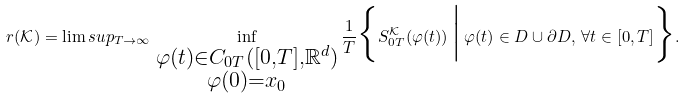Convert formula to latex. <formula><loc_0><loc_0><loc_500><loc_500>r ( \mathcal { K } ) = \lim s u p _ { T \rightarrow \infty } \, \inf _ { \substack { \varphi ( t ) \in C _ { 0 T } ( [ 0 , T ] , \mathbb { R } ^ { d } ) \\ \varphi ( 0 ) = x _ { 0 } } } \frac { 1 } { T } \Big \{ S _ { 0 T } ^ { \mathcal { K } } ( \varphi ( t ) ) \, \Big | \, \varphi ( t ) \in D \cup \partial D , \, \forall t \in [ 0 , T ] \Big \} .</formula> 